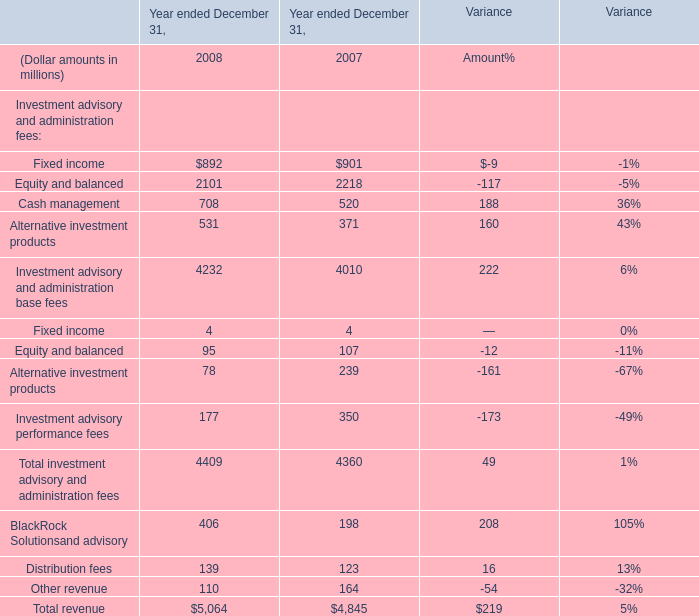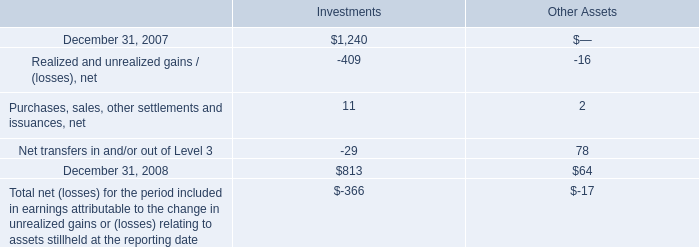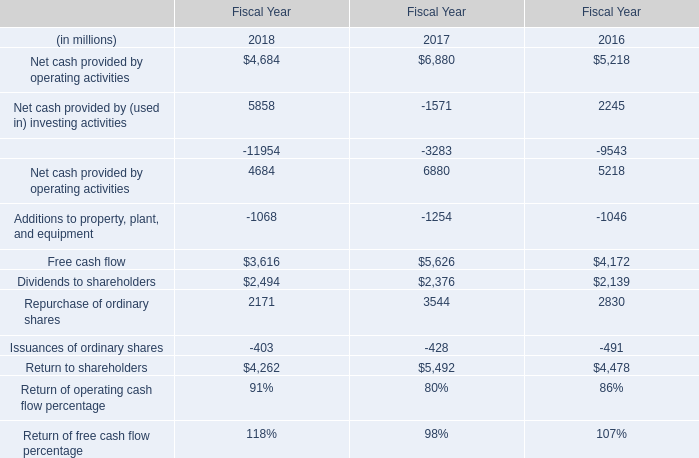what is the percentage change in the balance of level 3 investments assets from 2007 to 2008? 
Computations: ((813 - 1240) / 1240)
Answer: -0.34435. 